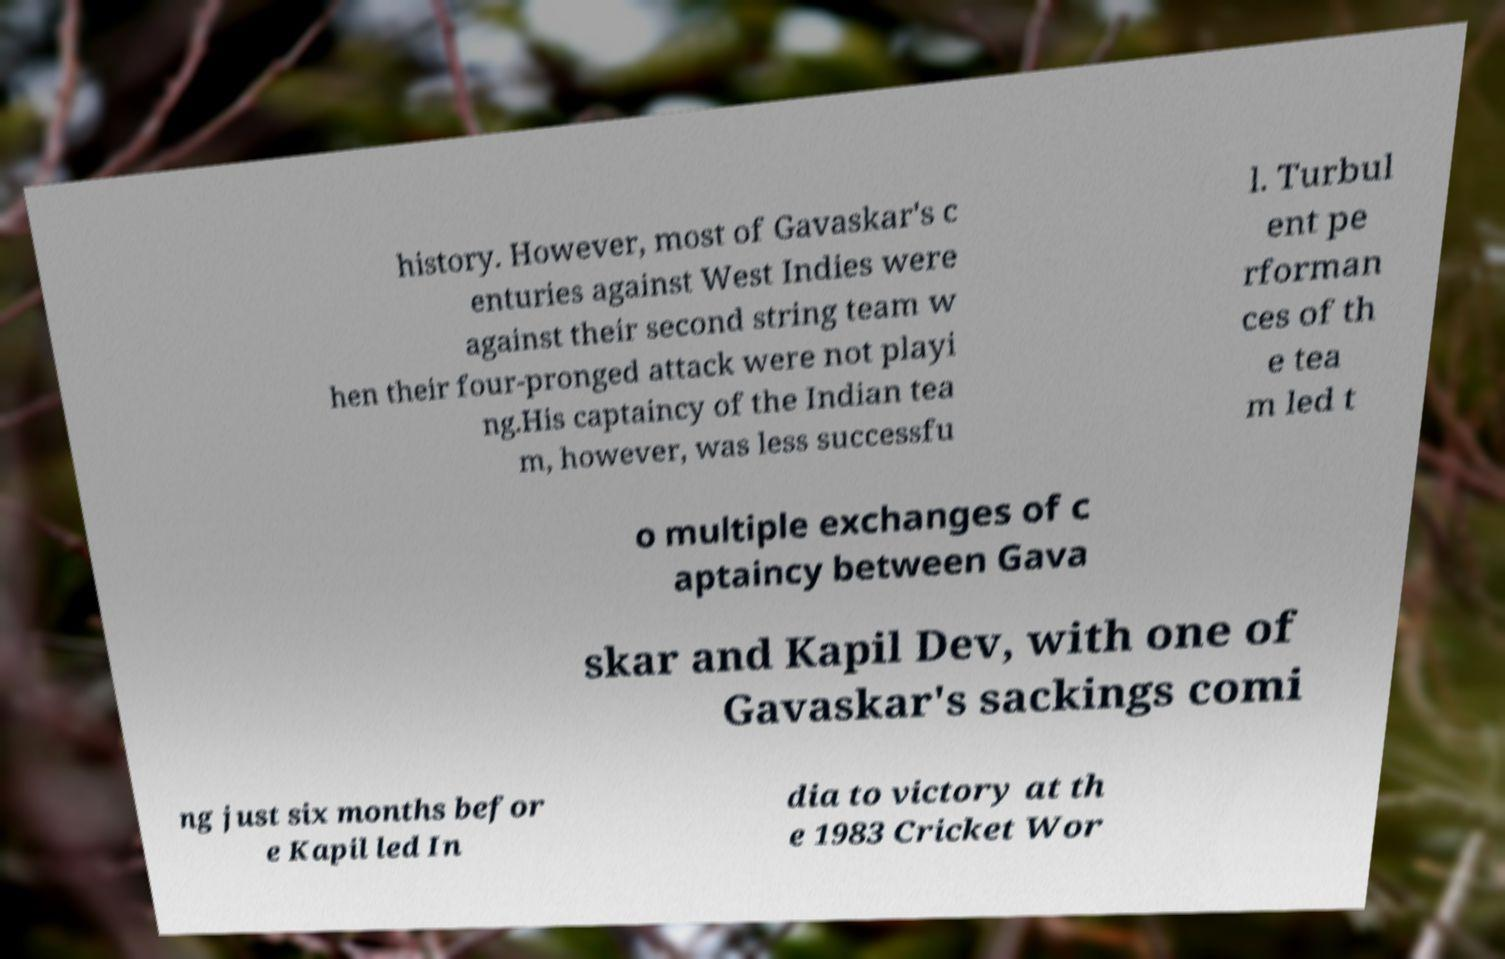Please read and relay the text visible in this image. What does it say? history. However, most of Gavaskar's c enturies against West Indies were against their second string team w hen their four-pronged attack were not playi ng.His captaincy of the Indian tea m, however, was less successfu l. Turbul ent pe rforman ces of th e tea m led t o multiple exchanges of c aptaincy between Gava skar and Kapil Dev, with one of Gavaskar's sackings comi ng just six months befor e Kapil led In dia to victory at th e 1983 Cricket Wor 